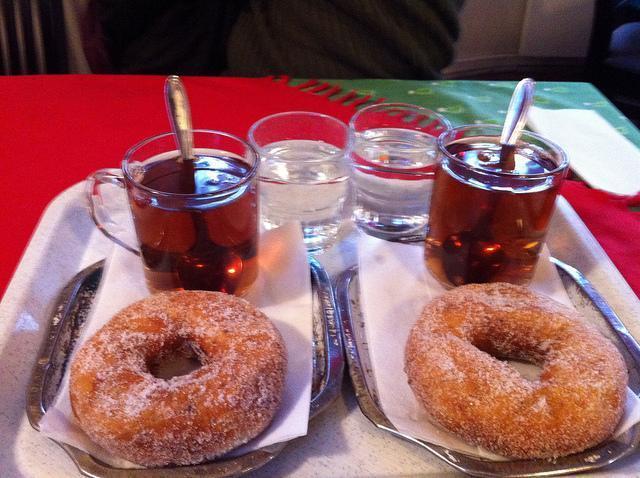How many people are probably going to eat this food?
Give a very brief answer. 2. How many donuts are pictured here?
Give a very brief answer. 2. How many donuts can be seen?
Give a very brief answer. 2. How many cups are in the picture?
Give a very brief answer. 4. How many spoons are in the photo?
Give a very brief answer. 2. How many toothbrushes in the photo?
Give a very brief answer. 0. 